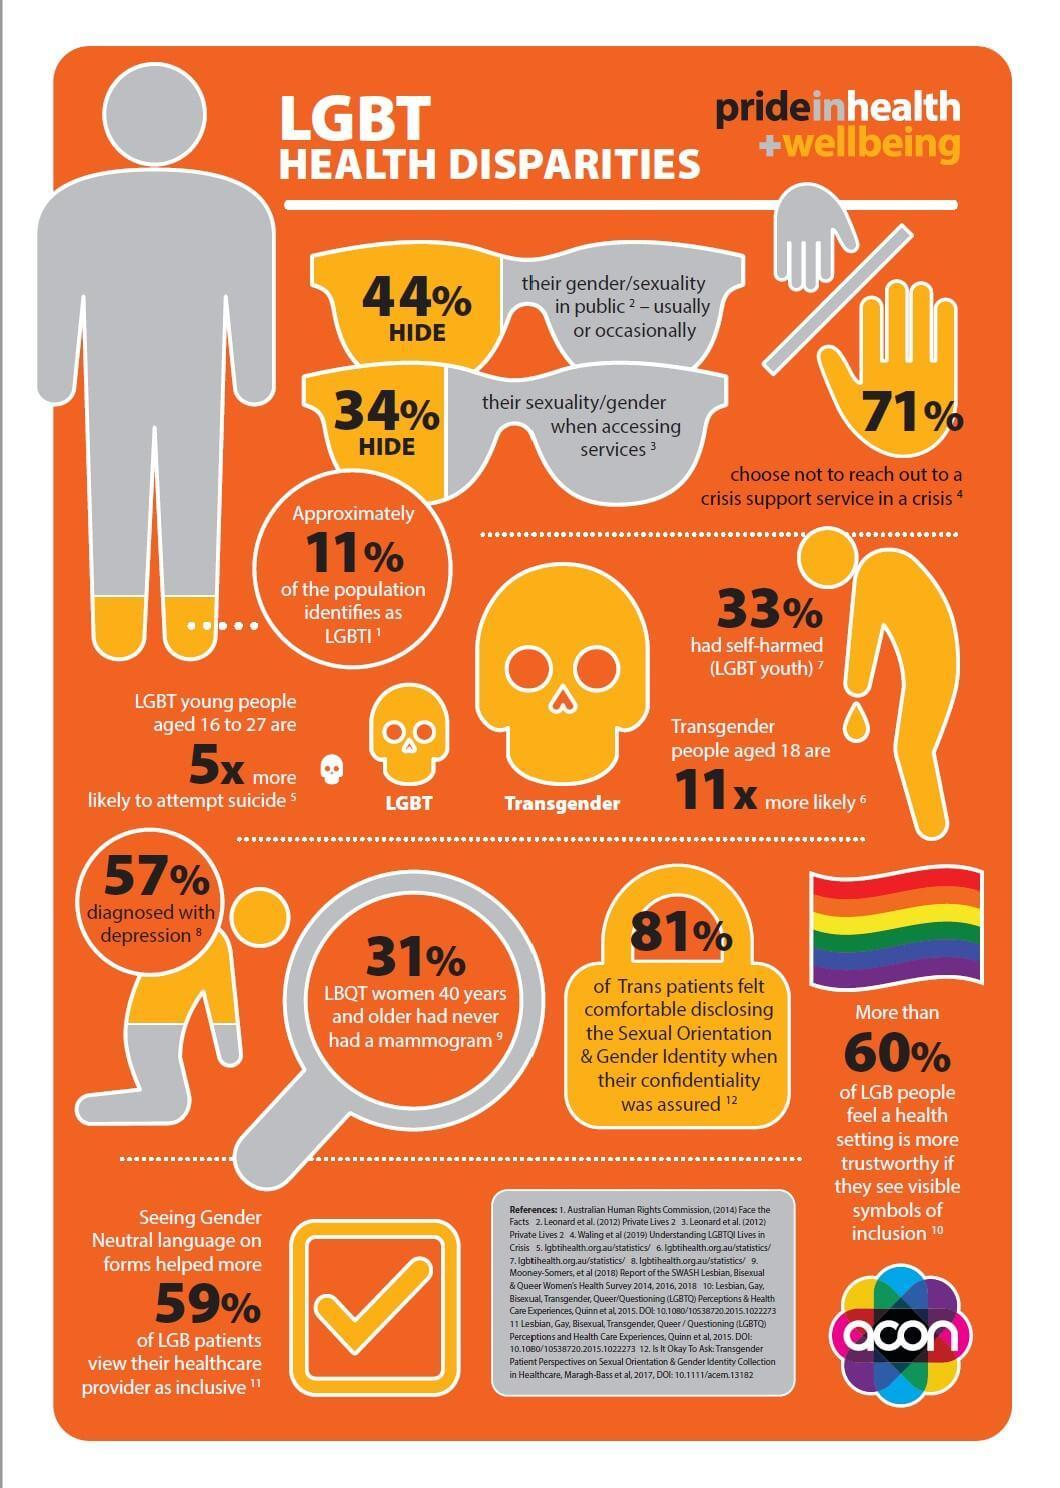How many choose not to reach out to a crisis support service in a crisis?
Answer the question with a short phrase. 71% How many are diagnosed with depression? 57% What percentage of population identifies as LGBTI? 11% What percentage of LGBT youth had self-harmed? 33% 